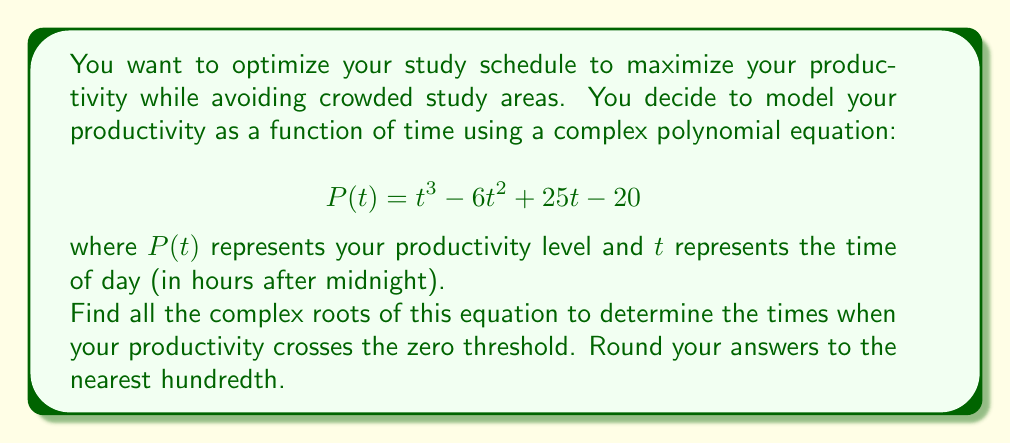Give your solution to this math problem. Let's solve this step-by-step:

1) We need to solve the equation $P(t) = 0$:

   $$ t^3 - 6t^2 + 25t - 20 = 0 $$

2) This is a cubic equation. We can use the rational root theorem to find one real root, then factor out that root to find the other two.

3) Possible rational roots are factors of 20: ±1, ±2, ±4, ±5, ±10, ±20

4) Testing these values, we find that $t = 1$ is a root.

5) We can factor out $(t-1)$:

   $$ t^3 - 6t^2 + 25t - 20 = (t-1)(t^2 - 5t + 20) = 0 $$

6) Now we need to solve $t^2 - 5t + 20 = 0$

7) Using the quadratic formula: $t = \frac{-b \pm \sqrt{b^2 - 4ac}}{2a}$

   $$ t = \frac{5 \pm \sqrt{25 - 80}}{2} = \frac{5 \pm \sqrt{-55}}{2} $$

8) Simplify:

   $$ t = \frac{5 \pm i\sqrt{55}}{2} $$

9) Calculate the real and imaginary parts:

   Real part: $\frac{5}{2} = 2.5$
   Imaginary part: $\frac{\sqrt{55}}{2} \approx 3.71$

10) Therefore, the three roots are:
    $t_1 = 1$
    $t_2 = 2.5 + 3.71i$
    $t_3 = 2.5 - 3.71i$
Answer: $t = 1$, $t = 2.50 + 3.71i$, $t = 2.50 - 3.71i$ 